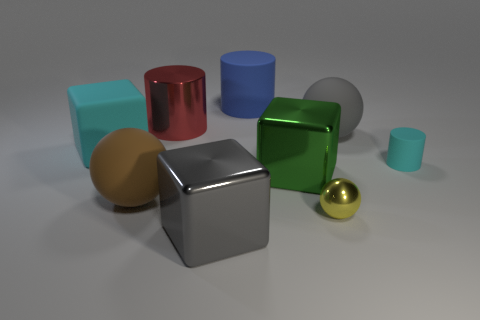Subtract all gray shiny cubes. How many cubes are left? 2 Subtract 1 cylinders. How many cylinders are left? 2 Add 2 large gray shiny things. How many large gray shiny things exist? 3 Subtract 1 cyan cylinders. How many objects are left? 8 Subtract all gray balls. Subtract all large gray metallic objects. How many objects are left? 7 Add 1 big cubes. How many big cubes are left? 4 